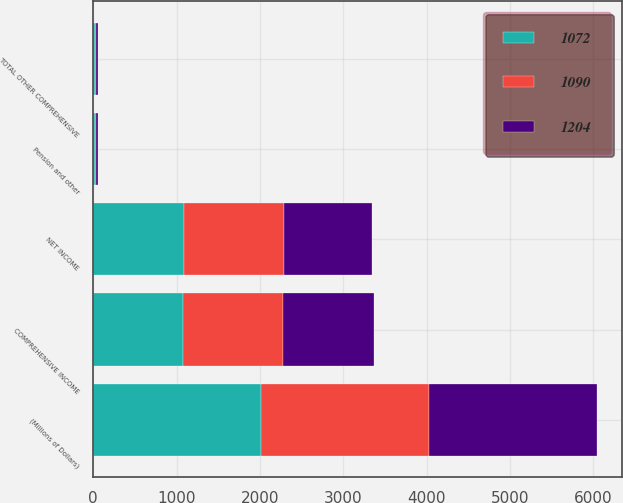Convert chart. <chart><loc_0><loc_0><loc_500><loc_500><stacked_bar_chart><ecel><fcel>(Millions of Dollars)<fcel>NET INCOME<fcel>Pension and other<fcel>TOTAL OTHER COMPREHENSIVE<fcel>COMPREHENSIVE INCOME<nl><fcel>1090<fcel>2015<fcel>1193<fcel>11<fcel>11<fcel>1204<nl><fcel>1072<fcel>2014<fcel>1092<fcel>20<fcel>20<fcel>1072<nl><fcel>1204<fcel>2013<fcel>1062<fcel>28<fcel>28<fcel>1090<nl></chart> 